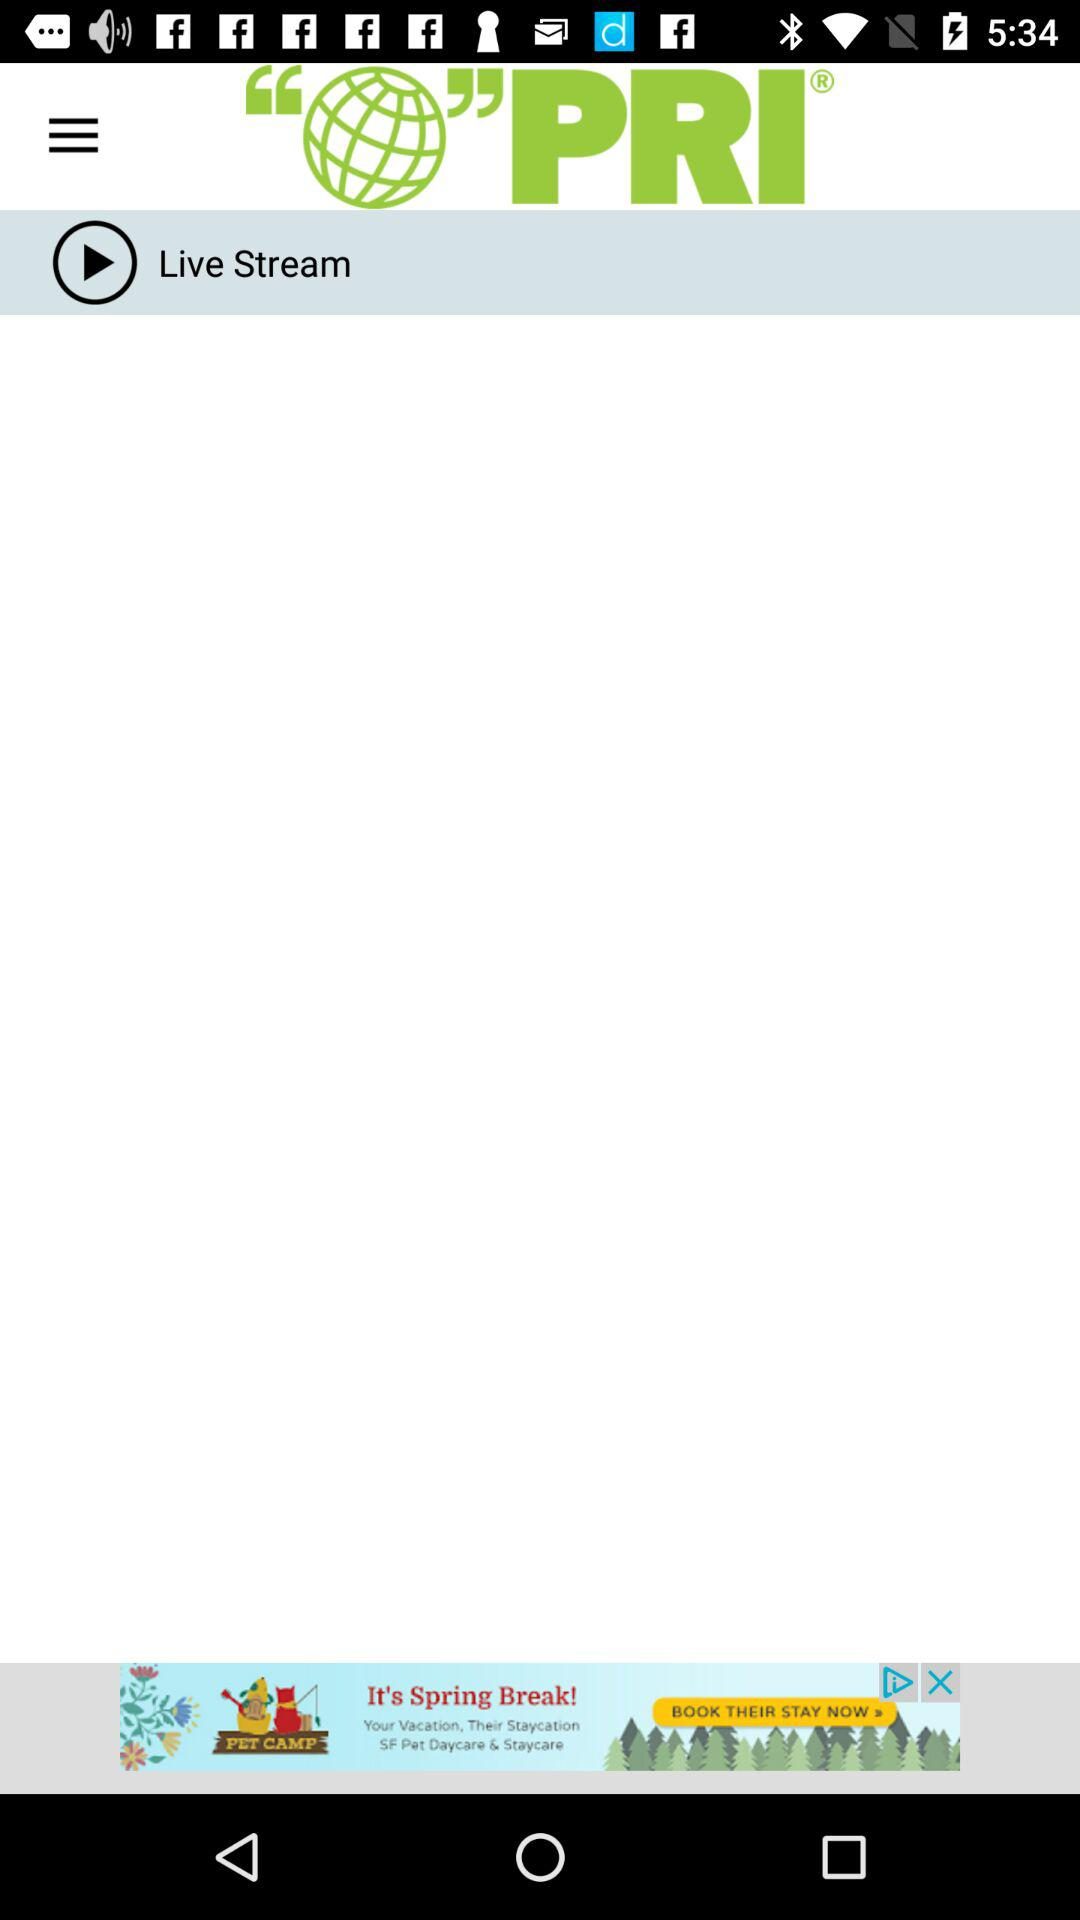What is the name of the application? The application name is "PRI®". 